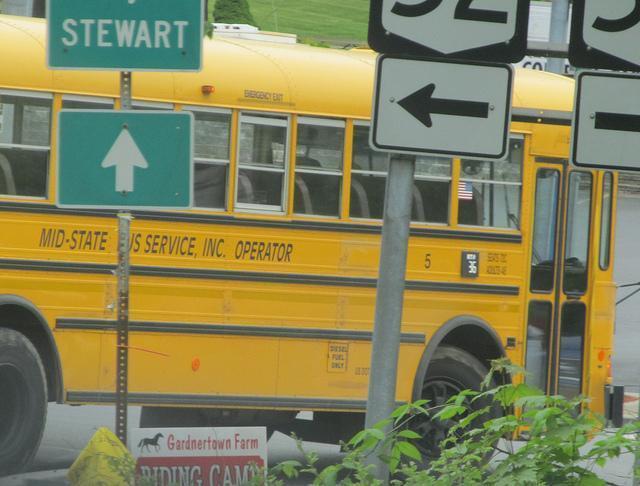How many arrows do you see in this picture?
Give a very brief answer. 2. How many pizzas are ready?
Give a very brief answer. 0. 